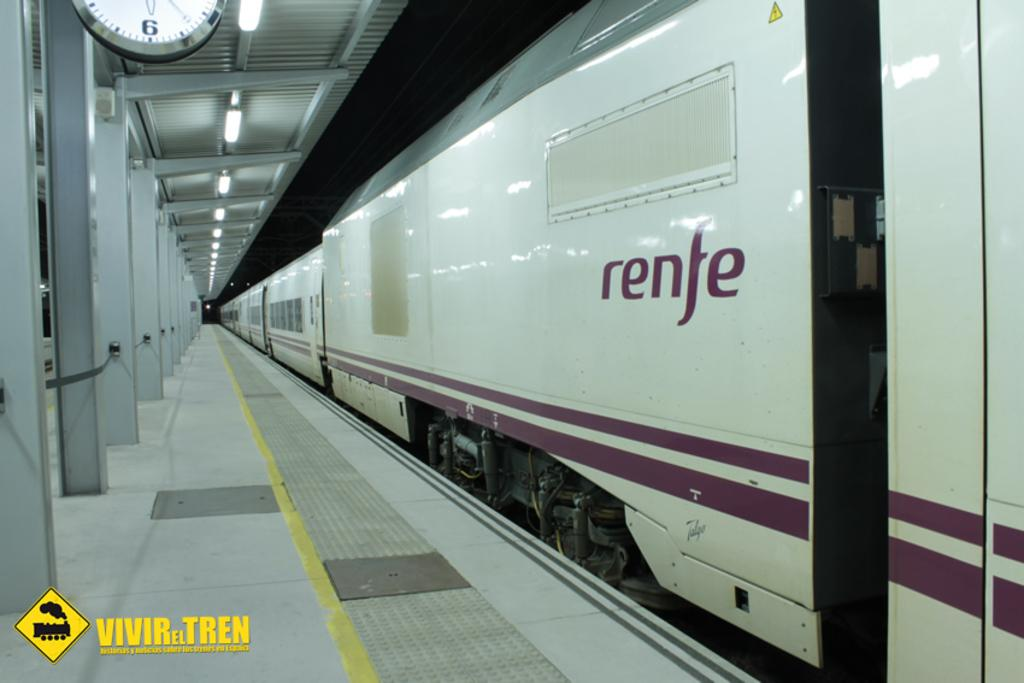Provide a one-sentence caption for the provided image. A train that says renfe on the side is stopped at the station. 